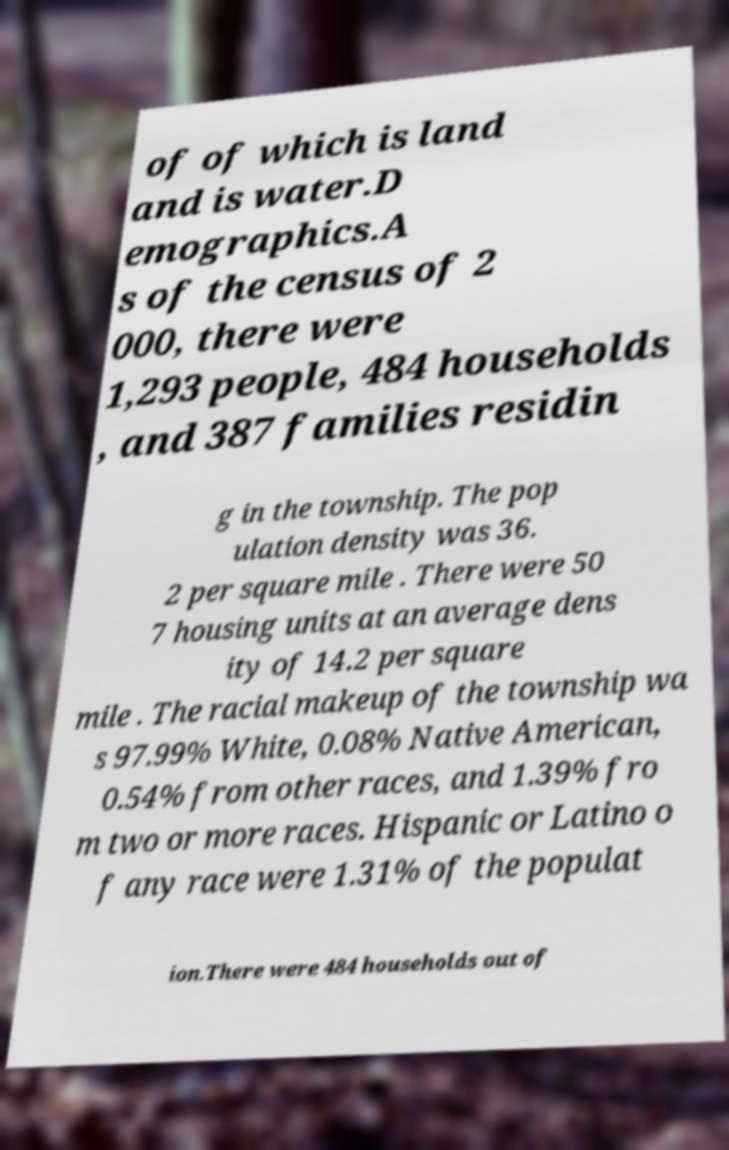I need the written content from this picture converted into text. Can you do that? of of which is land and is water.D emographics.A s of the census of 2 000, there were 1,293 people, 484 households , and 387 families residin g in the township. The pop ulation density was 36. 2 per square mile . There were 50 7 housing units at an average dens ity of 14.2 per square mile . The racial makeup of the township wa s 97.99% White, 0.08% Native American, 0.54% from other races, and 1.39% fro m two or more races. Hispanic or Latino o f any race were 1.31% of the populat ion.There were 484 households out of 